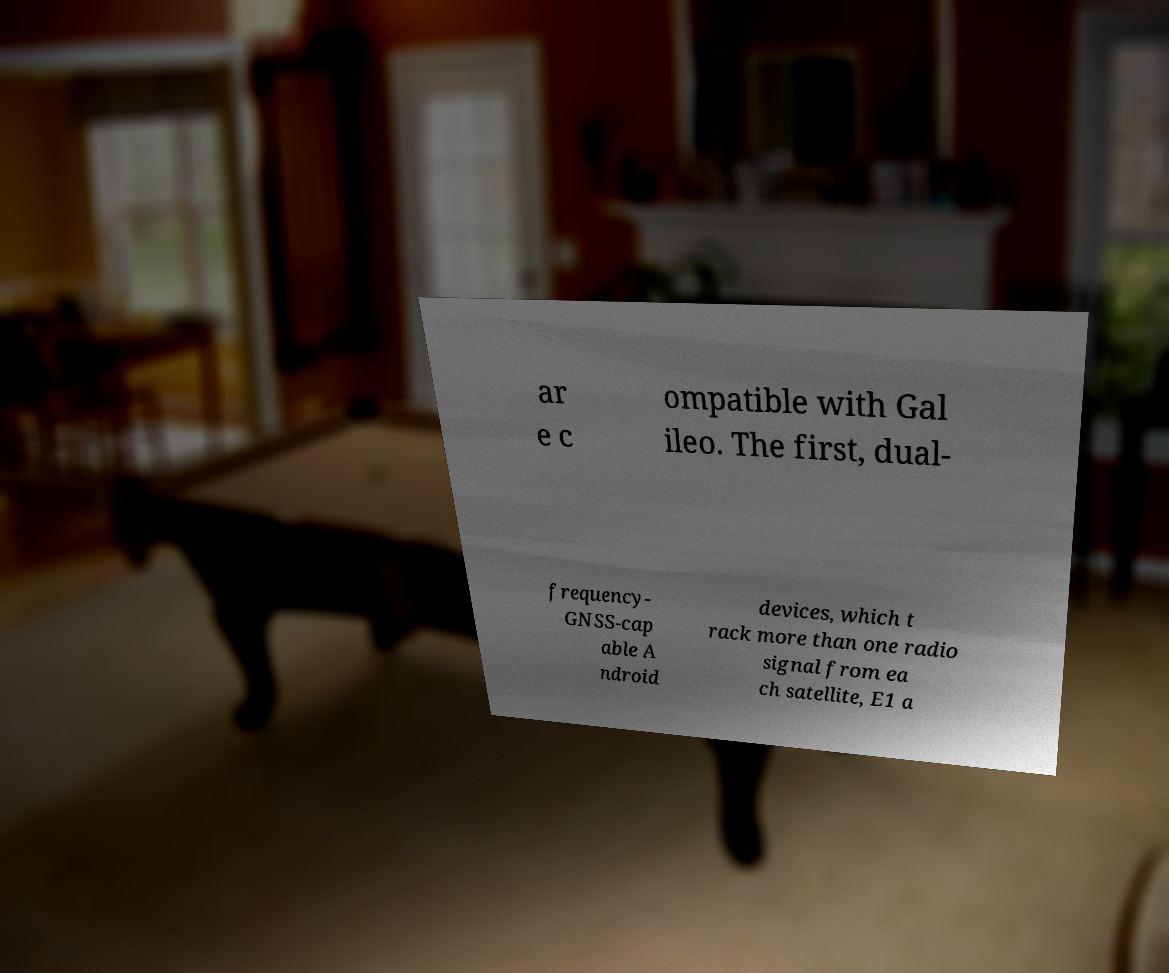What messages or text are displayed in this image? I need them in a readable, typed format. ar e c ompatible with Gal ileo. The first, dual- frequency- GNSS-cap able A ndroid devices, which t rack more than one radio signal from ea ch satellite, E1 a 